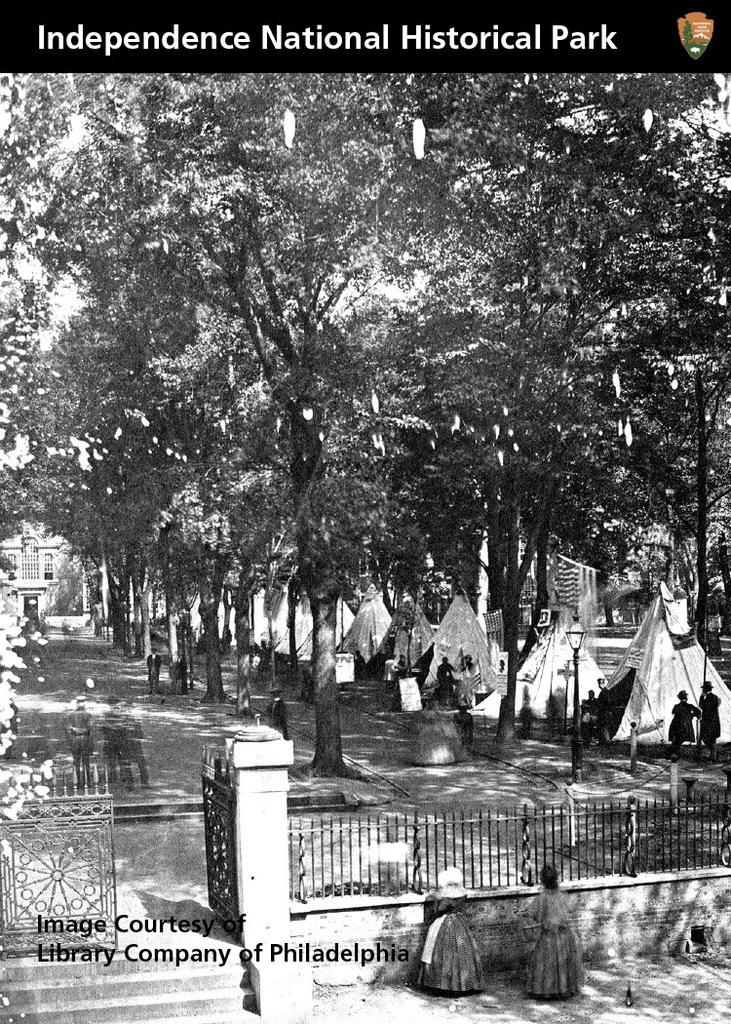What is the color scheme of the image? The image is black and white. What type of structure can be seen in the image? There is a fencing and a gate in the image. What type of natural elements are present in the image? There are trees in the image. Are there any people in the image? Yes, there are people in the image. Where are the tents located in the image? The tents are located at the right side of the image. Can you see a snake slithering through the grass in the image? There is no snake present in the image. What type of board game is being played by the people in the image? There is no board game visible in the image; it features a fencing, gate, trees, people, and tents. 